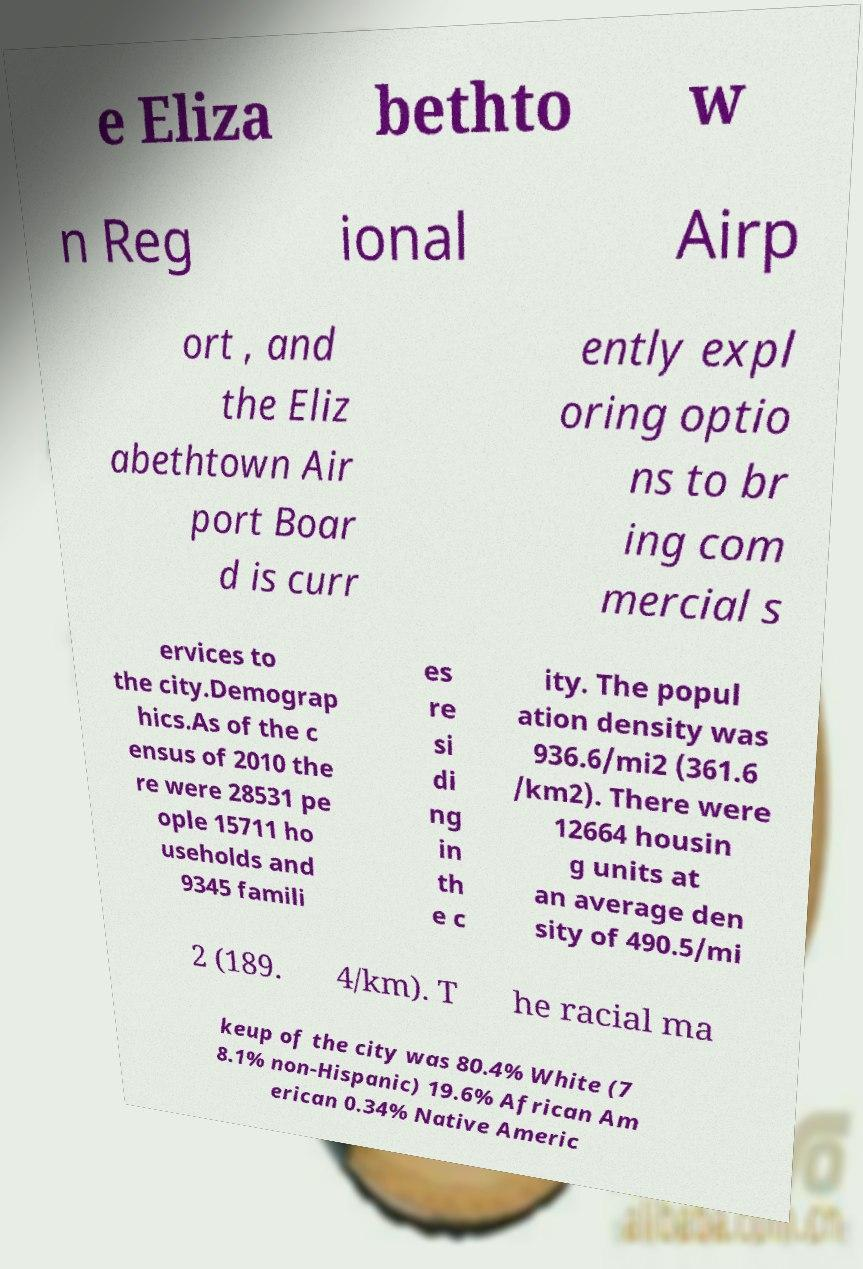I need the written content from this picture converted into text. Can you do that? e Eliza bethto w n Reg ional Airp ort , and the Eliz abethtown Air port Boar d is curr ently expl oring optio ns to br ing com mercial s ervices to the city.Demograp hics.As of the c ensus of 2010 the re were 28531 pe ople 15711 ho useholds and 9345 famili es re si di ng in th e c ity. The popul ation density was 936.6/mi2 (361.6 /km2). There were 12664 housin g units at an average den sity of 490.5/mi 2 (189. 4/km). T he racial ma keup of the city was 80.4% White (7 8.1% non-Hispanic) 19.6% African Am erican 0.34% Native Americ 